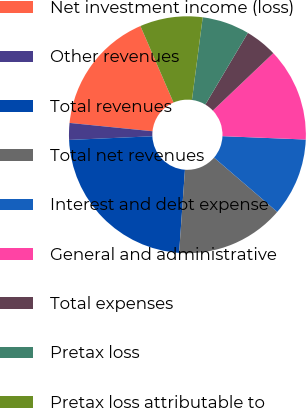Convert chart to OTSL. <chart><loc_0><loc_0><loc_500><loc_500><pie_chart><fcel>Net investment income (loss)<fcel>Other revenues<fcel>Total revenues<fcel>Total net revenues<fcel>Interest and debt expense<fcel>General and administrative<fcel>Total expenses<fcel>Pretax loss<fcel>Pretax loss attributable to<nl><fcel>16.92%<fcel>2.29%<fcel>23.19%<fcel>14.83%<fcel>10.65%<fcel>12.74%<fcel>4.38%<fcel>6.47%<fcel>8.56%<nl></chart> 